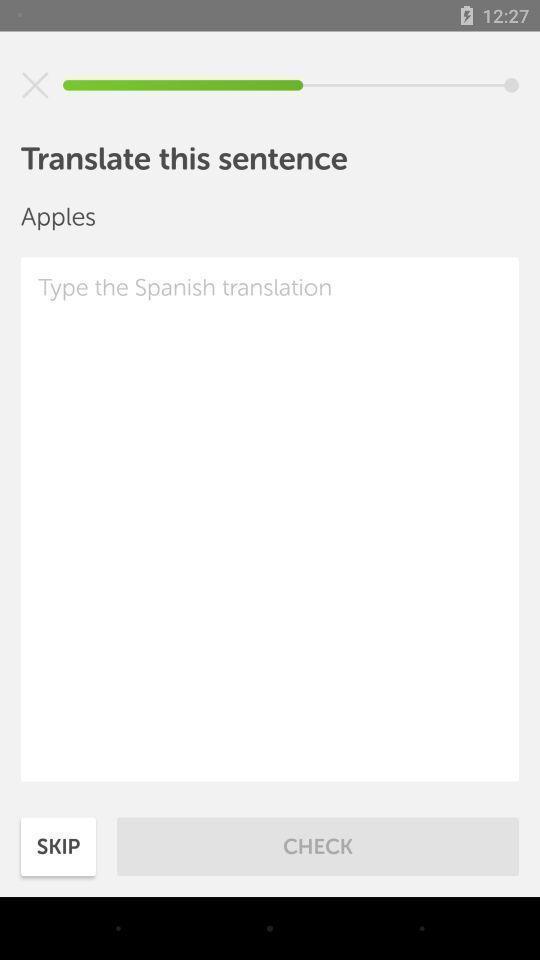Explain the elements present in this screenshot. Screen page of a language translator application. 